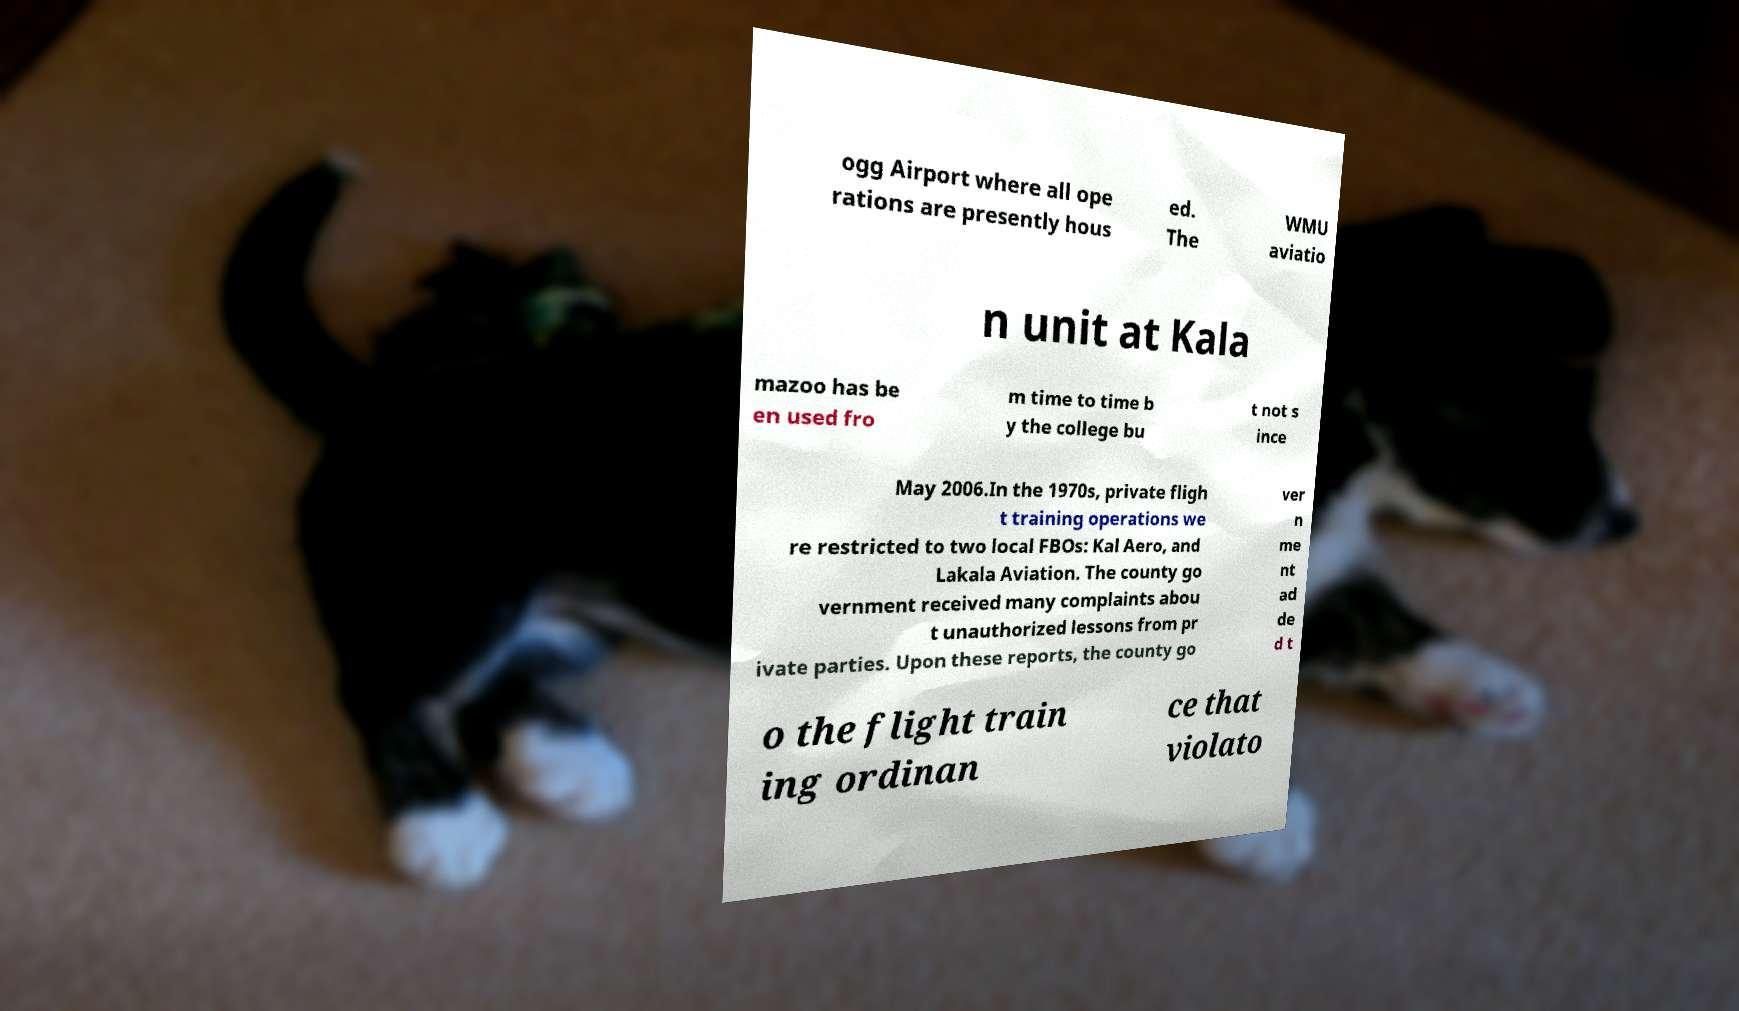For documentation purposes, I need the text within this image transcribed. Could you provide that? ogg Airport where all ope rations are presently hous ed. The WMU aviatio n unit at Kala mazoo has be en used fro m time to time b y the college bu t not s ince May 2006.In the 1970s, private fligh t training operations we re restricted to two local FBOs: Kal Aero, and Lakala Aviation. The county go vernment received many complaints abou t unauthorized lessons from pr ivate parties. Upon these reports, the county go ver n me nt ad de d t o the flight train ing ordinan ce that violato 